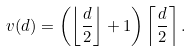<formula> <loc_0><loc_0><loc_500><loc_500>v ( d ) = \left ( \left \lfloor \frac { d } { 2 } \right \rfloor + 1 \right ) \left \lceil \frac { d } { 2 } \right \rceil .</formula> 